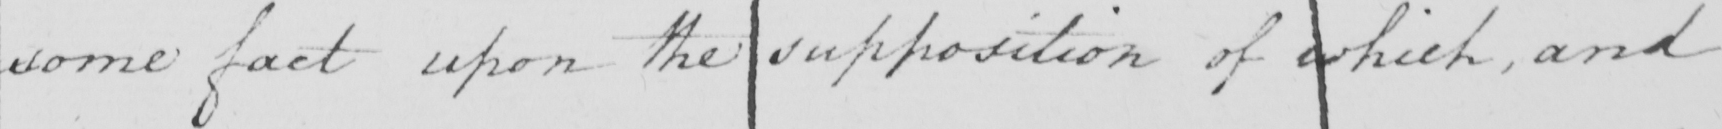Transcribe the text shown in this historical manuscript line. some fact upon the supposition of which , and 